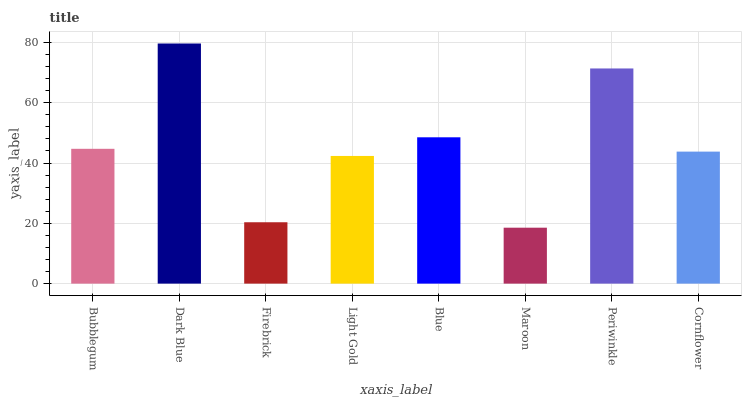Is Maroon the minimum?
Answer yes or no. Yes. Is Dark Blue the maximum?
Answer yes or no. Yes. Is Firebrick the minimum?
Answer yes or no. No. Is Firebrick the maximum?
Answer yes or no. No. Is Dark Blue greater than Firebrick?
Answer yes or no. Yes. Is Firebrick less than Dark Blue?
Answer yes or no. Yes. Is Firebrick greater than Dark Blue?
Answer yes or no. No. Is Dark Blue less than Firebrick?
Answer yes or no. No. Is Bubblegum the high median?
Answer yes or no. Yes. Is Cornflower the low median?
Answer yes or no. Yes. Is Firebrick the high median?
Answer yes or no. No. Is Periwinkle the low median?
Answer yes or no. No. 